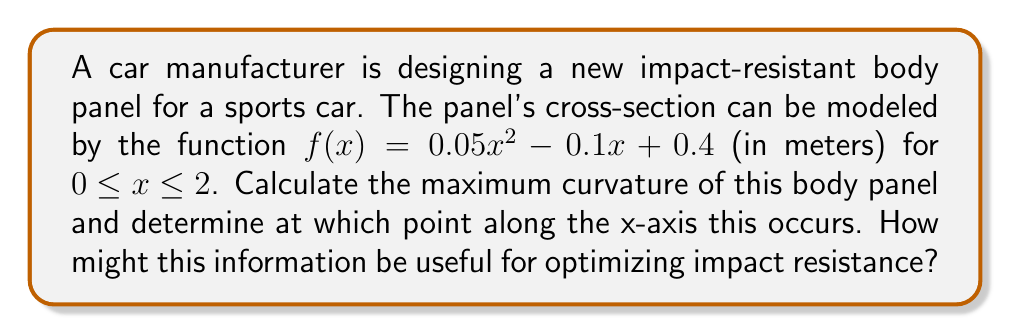Give your solution to this math problem. To solve this problem, we'll follow these steps:

1) The curvature $\kappa$ of a function $y = f(x)$ is given by the formula:

   $$\kappa = \frac{|f''(x)|}{(1 + [f'(x)]^2)^{3/2}}$$

2) First, let's find $f'(x)$ and $f''(x)$:
   
   $f'(x) = 0.1x - 0.1$
   $f''(x) = 0.1$

3) Now, we can substitute these into our curvature formula:

   $$\kappa = \frac{|0.1|}{(1 + [0.1x - 0.1]^2)^{3/2}}$$

4) To find the maximum curvature, we need to minimize the denominator. The denominator will be at its minimum when $[0.1x - 0.1]^2$ is at its minimum, which occurs when $0.1x - 0.1 = 0$, or when $x = 1$.

5) At $x = 1$, the curvature is:

   $$\kappa_{max} = \frac{0.1}{(1 + 0^2)^{3/2}} = 0.1 \text{ m}^{-1}$$

6) This maximum curvature occurs at the point $(1, f(1))$ on the body panel. We can calculate $f(1)$:

   $f(1) = 0.05(1)^2 - 0.1(1) + 0.4 = 0.35$ meters

So, the point of maximum curvature is $(1, 0.35)$ meters.

This information is crucial for optimizing impact resistance. The point of maximum curvature is likely to be the most vulnerable to impact, as it experiences the greatest stress concentration. Automotive engineers can use this information to reinforce this area, possibly by increasing material thickness or using stronger materials at this point. They might also consider redesigning the panel to distribute curvature more evenly, potentially improving overall impact resistance.

[asy]
import graph;
size(200,150);
real f(real x) {return 0.05x^2 - 0.1x + 0.4;}
draw(graph(f,0,2));
dot((1,f(1)),red);
label("Point of max curvature",(1,f(1)),NE,red);
xaxis("x",arrow=Arrow);
yaxis("y",arrow=Arrow);
[/asy]
Answer: The maximum curvature is $0.1 \text{ m}^{-1}$, occurring at the point $(1, 0.35)$ meters on the body panel. 